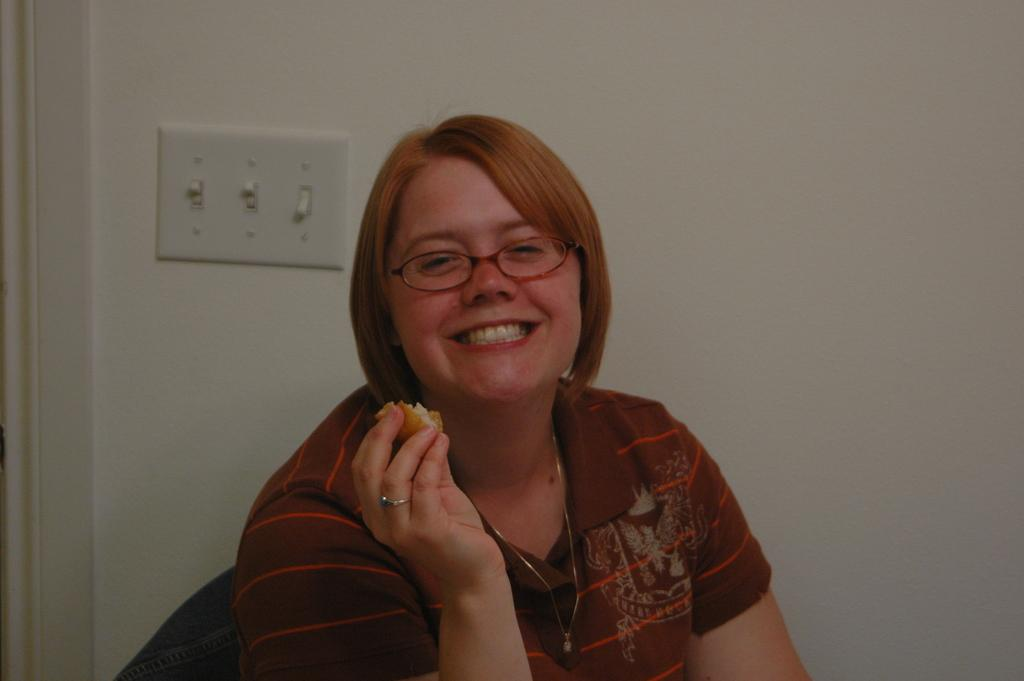Who is present in the image? There is a woman in the image. What is the woman doing in the image? The woman is sitting and holding a food item in her hand. What is the woman's facial expression in the image? The woman is smiling in the image. What can be seen on the wall in the image? There is a switchboard on the wall in the image. How many trees can be seen in the image? There are no trees visible in the image. What type of food item is the woman sorting in the image? The woman is not sorting any food item in the image; she is holding a food item in her hand. 